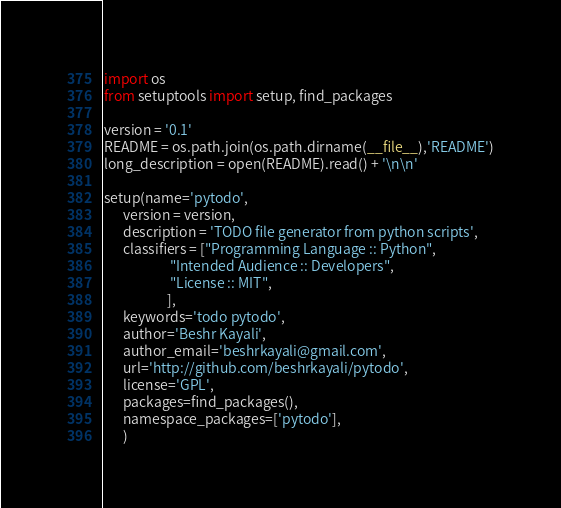<code> <loc_0><loc_0><loc_500><loc_500><_Python_>import os
from setuptools import setup, find_packages

version = '0.1'
README = os.path.join(os.path.dirname(__file__),'README')
long_description = open(README).read() + '\n\n'

setup(name='pytodo',
	  version = version,
	  description = 'TODO file generator from python scripts',
	  classifiers = ["Programming Language :: Python",
	  				 "Intended Audience :: Developers",
	  				 "License :: MIT",	  				 
	  				],
	  keywords='todo pytodo',
	  author='Beshr Kayali',
	  author_email='beshrkayali@gmail.com',
	  url='http://github.com/beshrkayali/pytodo',
	  license='GPL',
	  packages=find_packages(),
	  namespace_packages=['pytodo'],
	  )
</code> 